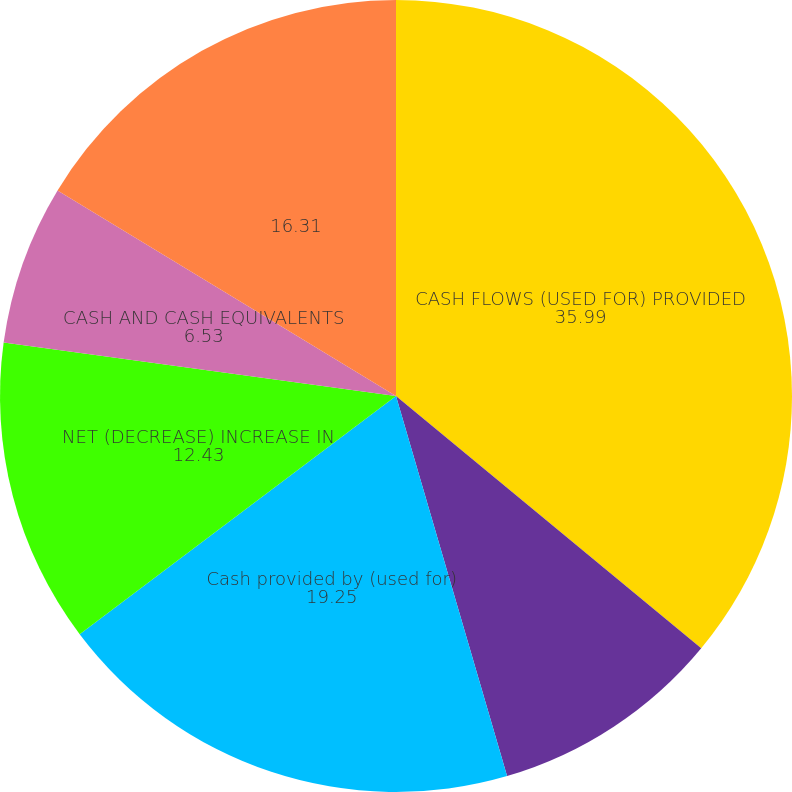Convert chart to OTSL. <chart><loc_0><loc_0><loc_500><loc_500><pie_chart><fcel>CASH FLOWS (USED FOR) PROVIDED<fcel>Cash (used for) provided by<fcel>Cash provided by (used for)<fcel>NET (DECREASE) INCREASE IN<fcel>CASH AND CASH EQUIVALENTS<fcel>Unnamed: 5<nl><fcel>35.99%<fcel>9.48%<fcel>19.25%<fcel>12.43%<fcel>6.53%<fcel>16.31%<nl></chart> 